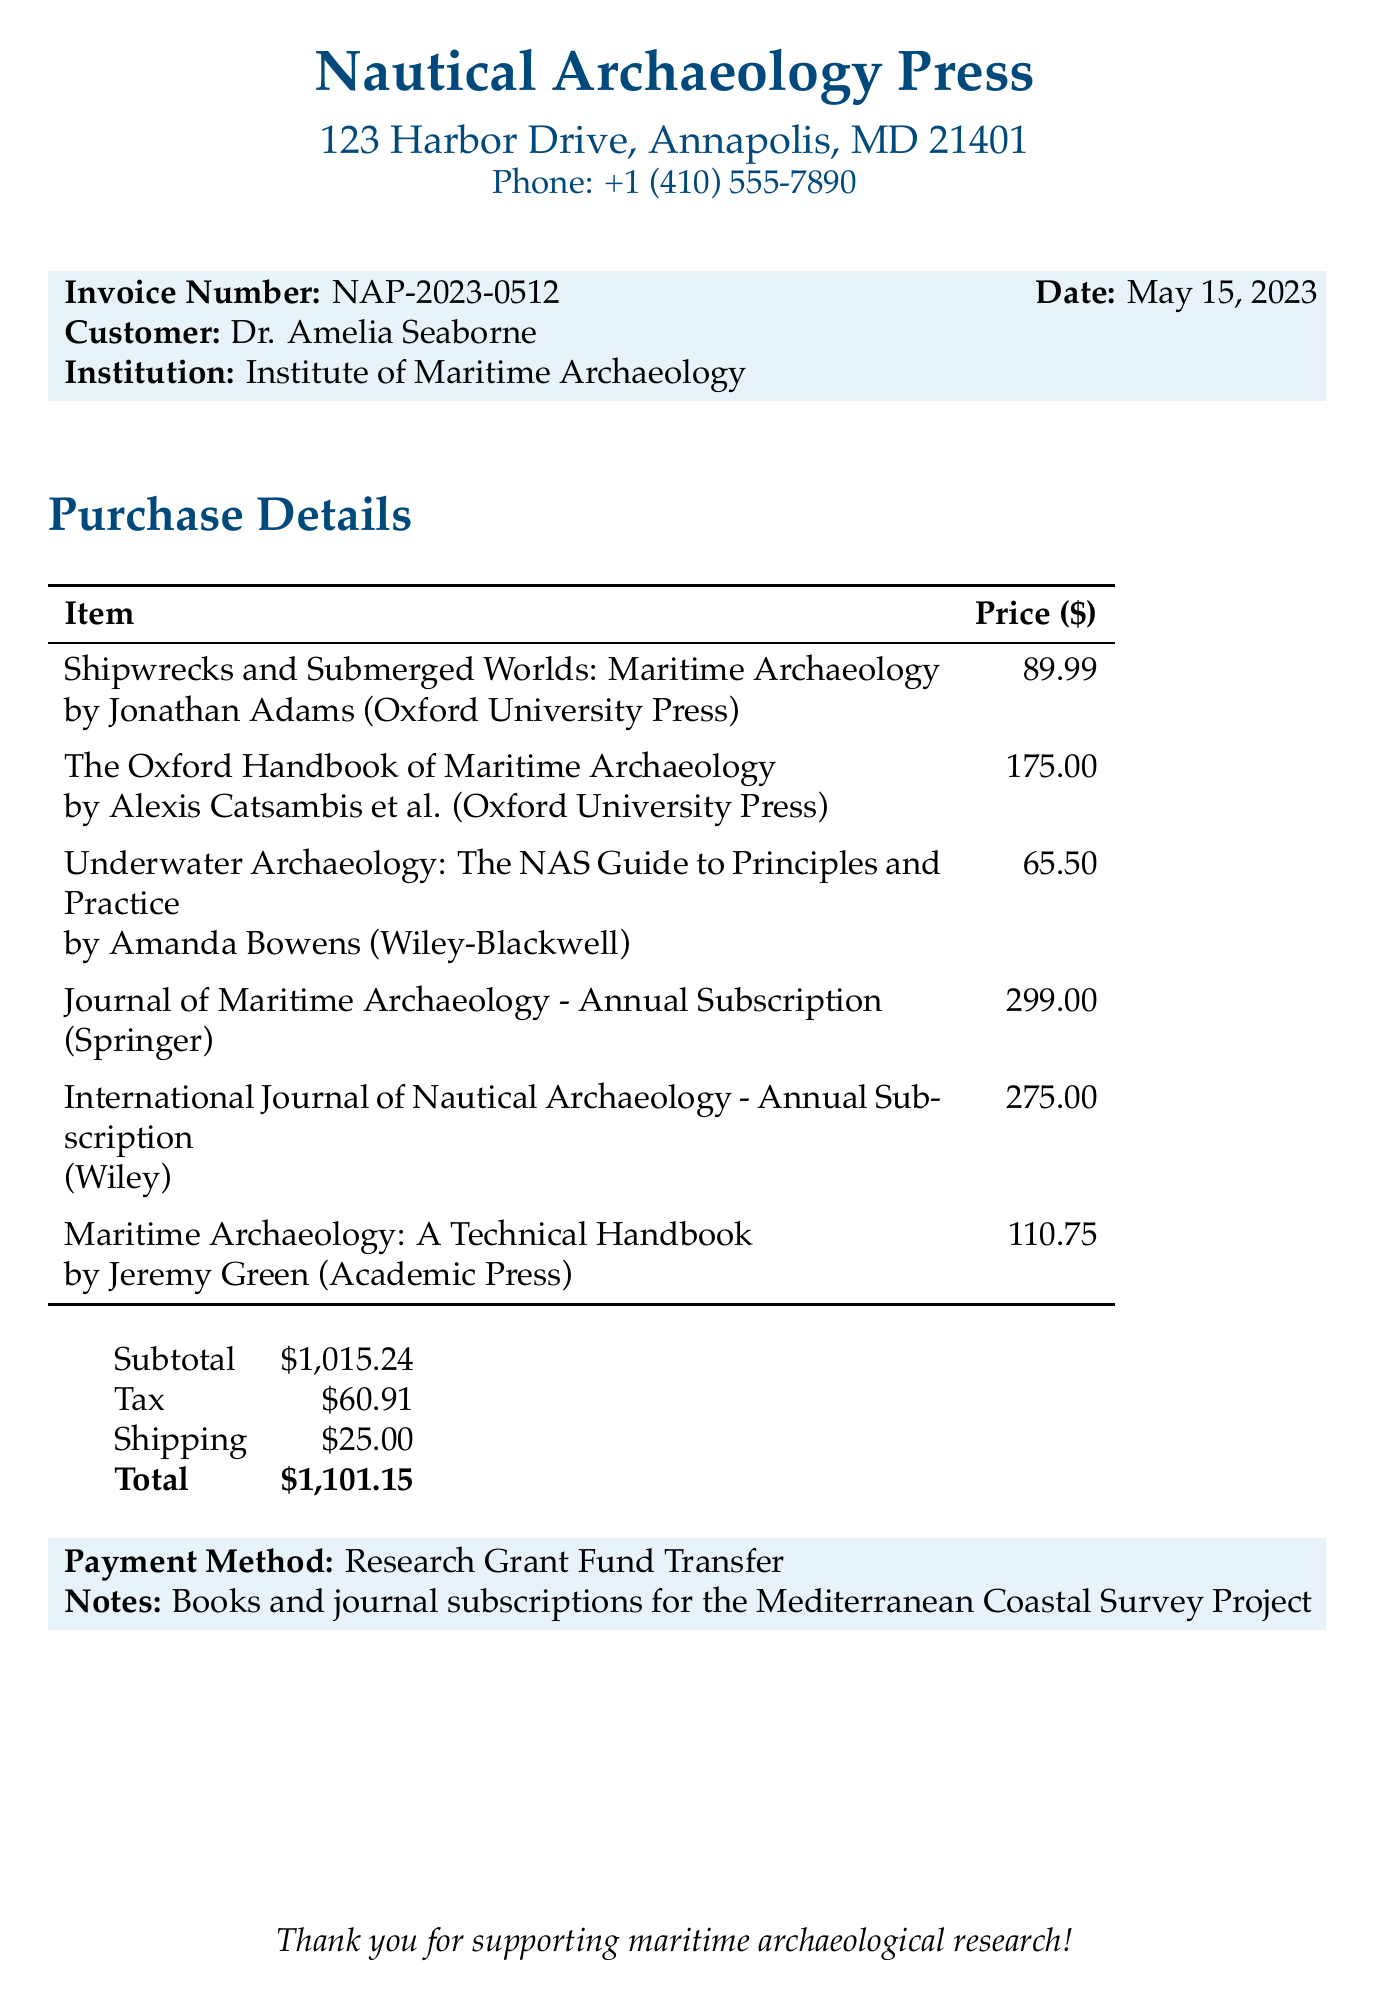What is the invoice number? The invoice number is specifically listed in the document under the invoice details.
Answer: NAP-2023-0512 What is the total amount due? The total amount due is the final amount calculated at the bottom of the document.
Answer: $1,101.15 Who is the author of "Underwater Archaeology: The NAS Guide to Principles and Practice"? The author is mentioned alongside the book title, providing clear attribution.
Answer: Amanda Bowens What is the cost of the "Journal of Maritime Archaeology" subscription? The price for the subscription is specified directly in the purchase details table.
Answer: $299.00 What payment method was used? The payment method is explicitly stated in the notes section of the document.
Answer: Research Grant Fund Transfer How many items are listed in the purchase details? The number of items can be counted from the itemized list provided in the document.
Answer: 6 What is the subtotal before tax and shipping? The subtotal is the sum of the prices listed for all items before additional charges are applied.
Answer: $1,015.24 What type of document is this? The unique structure and content classify this document specifically as a purchase invoice.
Answer: Purchase invoice What institution is Dr. Amelia Seaborne affiliated with? The institution is mentioned directly under the customer details in the document.
Answer: Institute of Maritime Archaeology 